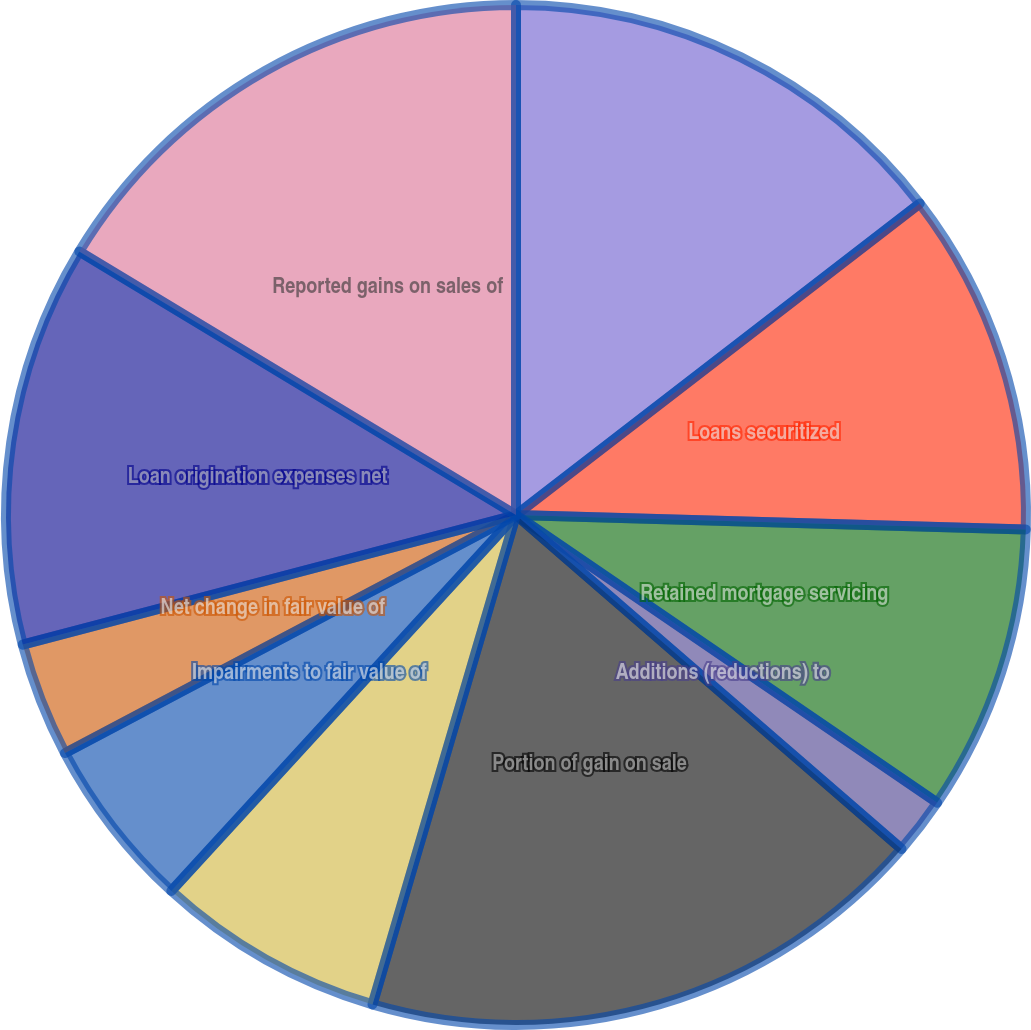Convert chart to OTSL. <chart><loc_0><loc_0><loc_500><loc_500><pie_chart><fcel>Whole loans sold by the Trusts<fcel>Loans securitized<fcel>Retained mortgage servicing<fcel>Additions (reductions) to<fcel>Portion of gain on sale<fcel>Changes in beneficial interest<fcel>Impairments to fair value of<fcel>Net change in fair value of<fcel>Loan origination expenses net<fcel>Reported gains on sales of<nl><fcel>14.54%<fcel>10.91%<fcel>9.09%<fcel>1.82%<fcel>18.18%<fcel>7.27%<fcel>5.46%<fcel>3.64%<fcel>12.73%<fcel>16.36%<nl></chart> 